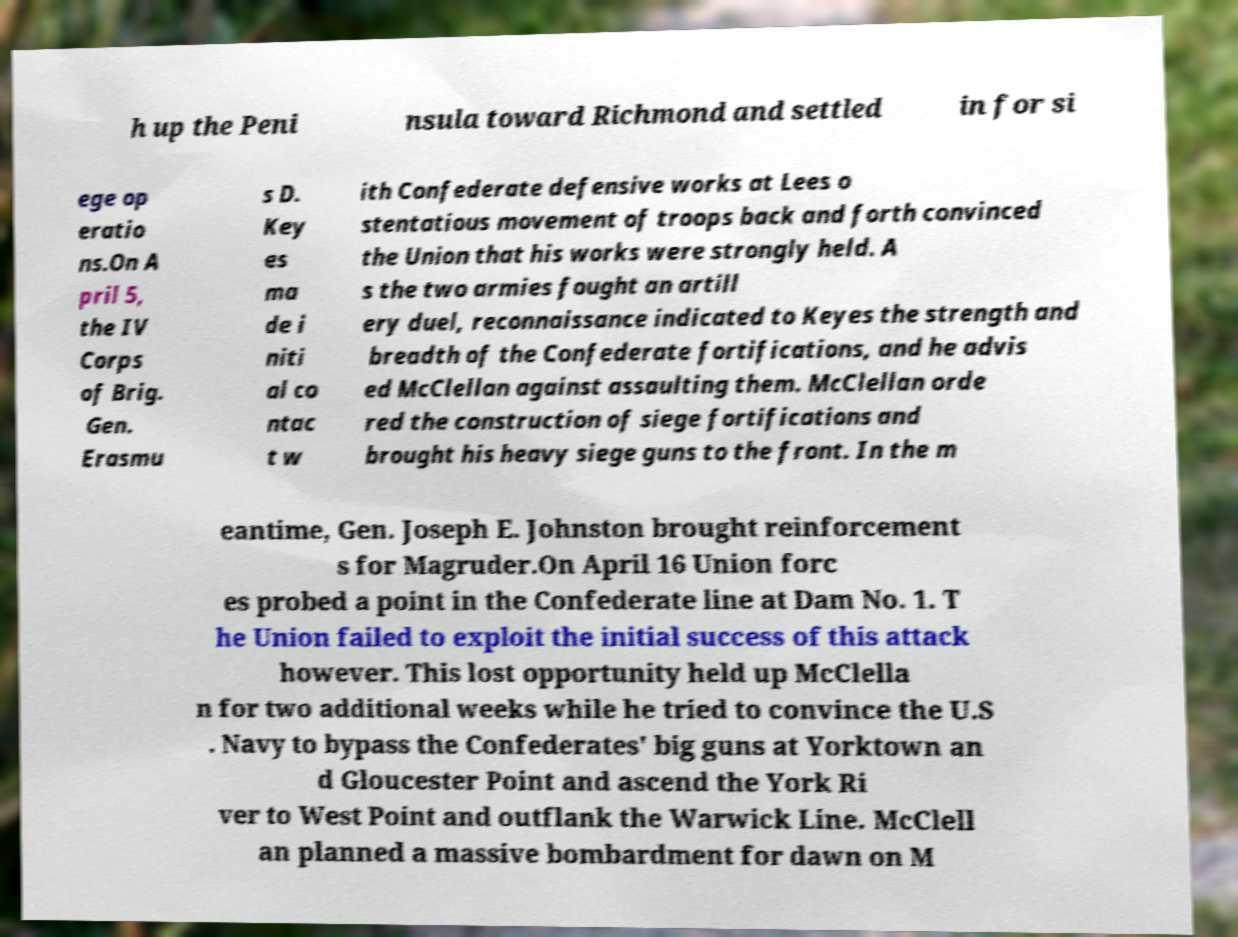I need the written content from this picture converted into text. Can you do that? h up the Peni nsula toward Richmond and settled in for si ege op eratio ns.On A pril 5, the IV Corps of Brig. Gen. Erasmu s D. Key es ma de i niti al co ntac t w ith Confederate defensive works at Lees o stentatious movement of troops back and forth convinced the Union that his works were strongly held. A s the two armies fought an artill ery duel, reconnaissance indicated to Keyes the strength and breadth of the Confederate fortifications, and he advis ed McClellan against assaulting them. McClellan orde red the construction of siege fortifications and brought his heavy siege guns to the front. In the m eantime, Gen. Joseph E. Johnston brought reinforcement s for Magruder.On April 16 Union forc es probed a point in the Confederate line at Dam No. 1. T he Union failed to exploit the initial success of this attack however. This lost opportunity held up McClella n for two additional weeks while he tried to convince the U.S . Navy to bypass the Confederates' big guns at Yorktown an d Gloucester Point and ascend the York Ri ver to West Point and outflank the Warwick Line. McClell an planned a massive bombardment for dawn on M 